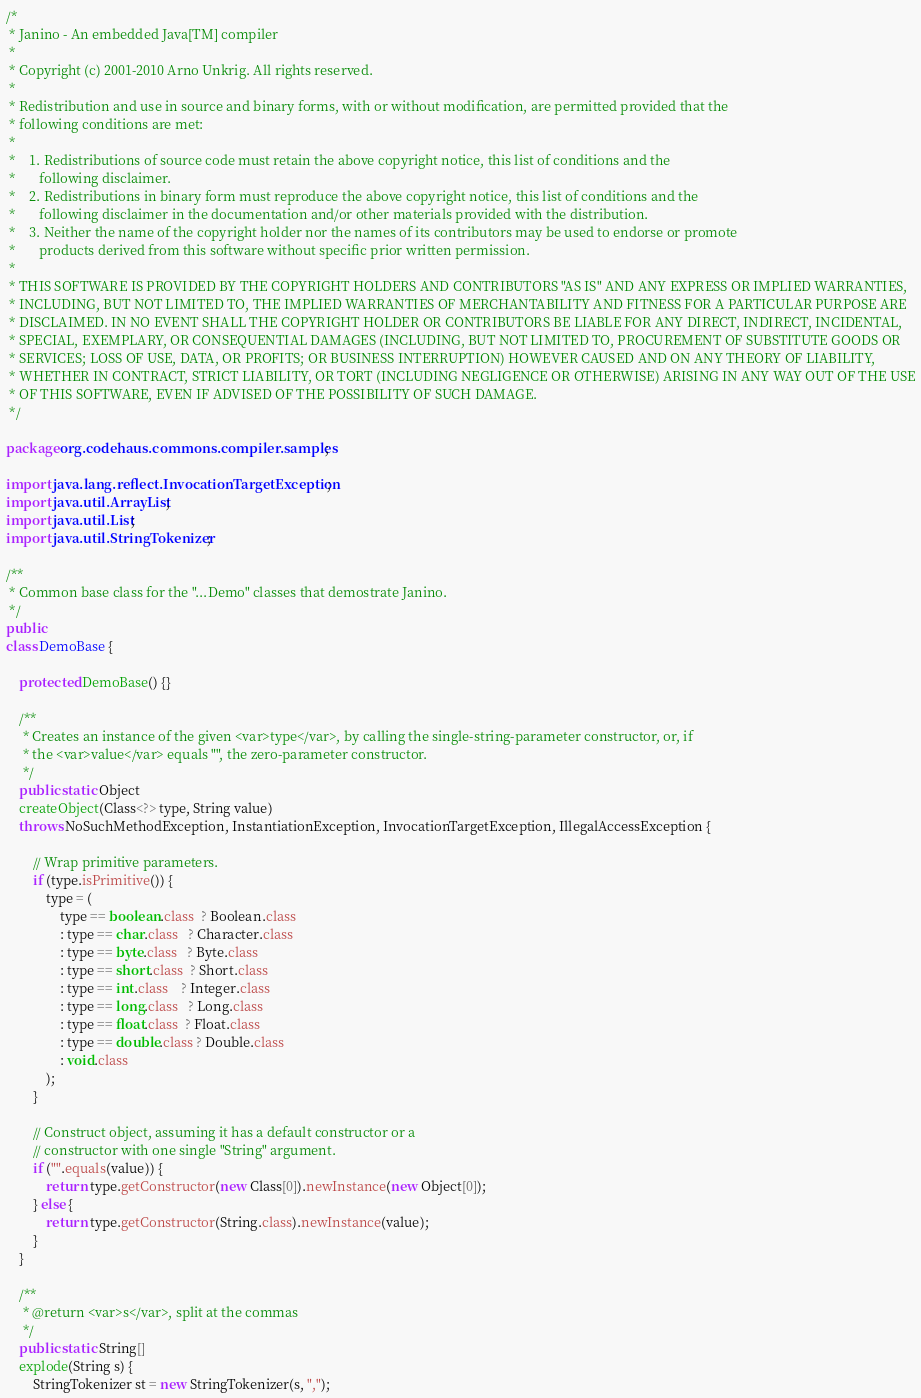<code> <loc_0><loc_0><loc_500><loc_500><_Java_>
/*
 * Janino - An embedded Java[TM] compiler
 *
 * Copyright (c) 2001-2010 Arno Unkrig. All rights reserved.
 *
 * Redistribution and use in source and binary forms, with or without modification, are permitted provided that the
 * following conditions are met:
 *
 *    1. Redistributions of source code must retain the above copyright notice, this list of conditions and the
 *       following disclaimer.
 *    2. Redistributions in binary form must reproduce the above copyright notice, this list of conditions and the
 *       following disclaimer in the documentation and/or other materials provided with the distribution.
 *    3. Neither the name of the copyright holder nor the names of its contributors may be used to endorse or promote
 *       products derived from this software without specific prior written permission.
 *
 * THIS SOFTWARE IS PROVIDED BY THE COPYRIGHT HOLDERS AND CONTRIBUTORS "AS IS" AND ANY EXPRESS OR IMPLIED WARRANTIES,
 * INCLUDING, BUT NOT LIMITED TO, THE IMPLIED WARRANTIES OF MERCHANTABILITY AND FITNESS FOR A PARTICULAR PURPOSE ARE
 * DISCLAIMED. IN NO EVENT SHALL THE COPYRIGHT HOLDER OR CONTRIBUTORS BE LIABLE FOR ANY DIRECT, INDIRECT, INCIDENTAL,
 * SPECIAL, EXEMPLARY, OR CONSEQUENTIAL DAMAGES (INCLUDING, BUT NOT LIMITED TO, PROCUREMENT OF SUBSTITUTE GOODS OR
 * SERVICES; LOSS OF USE, DATA, OR PROFITS; OR BUSINESS INTERRUPTION) HOWEVER CAUSED AND ON ANY THEORY OF LIABILITY,
 * WHETHER IN CONTRACT, STRICT LIABILITY, OR TORT (INCLUDING NEGLIGENCE OR OTHERWISE) ARISING IN ANY WAY OUT OF THE USE
 * OF THIS SOFTWARE, EVEN IF ADVISED OF THE POSSIBILITY OF SUCH DAMAGE.
 */

package org.codehaus.commons.compiler.samples;

import java.lang.reflect.InvocationTargetException;
import java.util.ArrayList;
import java.util.List;
import java.util.StringTokenizer;

/**
 * Common base class for the "...Demo" classes that demostrate Janino.
 */
public
class DemoBase {

    protected DemoBase() {}

    /**
     * Creates an instance of the given <var>type</var>, by calling the single-string-parameter constructor, or, if
     * the <var>value</var> equals "", the zero-parameter constructor.
     */
    public static Object
    createObject(Class<?> type, String value)
    throws NoSuchMethodException, InstantiationException, InvocationTargetException, IllegalAccessException {

        // Wrap primitive parameters.
        if (type.isPrimitive()) {
            type = (
                type == boolean.class  ? Boolean.class
                : type == char.class   ? Character.class
                : type == byte.class   ? Byte.class
                : type == short.class  ? Short.class
                : type == int.class    ? Integer.class
                : type == long.class   ? Long.class
                : type == float.class  ? Float.class
                : type == double.class ? Double.class
                : void.class
            );
        }

        // Construct object, assuming it has a default constructor or a
        // constructor with one single "String" argument.
        if ("".equals(value)) {
            return type.getConstructor(new Class[0]).newInstance(new Object[0]);
        } else {
            return type.getConstructor(String.class).newInstance(value);
        }
    }

    /**
     * @return <var>s</var>, split at the commas
     */
    public static String[]
    explode(String s) {
        StringTokenizer st = new StringTokenizer(s, ",");</code> 